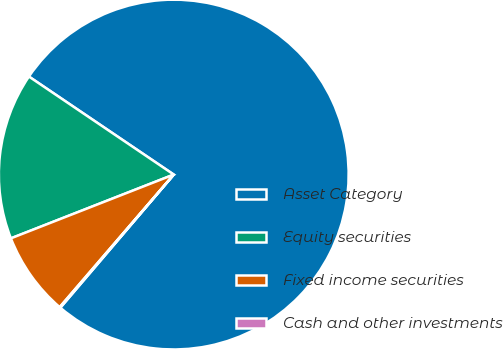Convert chart to OTSL. <chart><loc_0><loc_0><loc_500><loc_500><pie_chart><fcel>Asset Category<fcel>Equity securities<fcel>Fixed income securities<fcel>Cash and other investments<nl><fcel>76.76%<fcel>15.41%<fcel>7.75%<fcel>0.08%<nl></chart> 